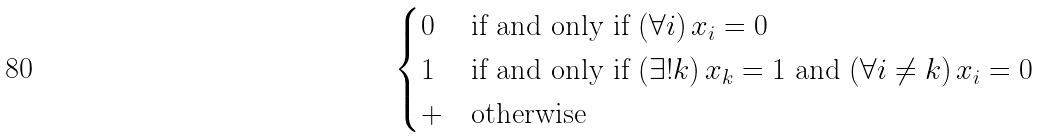Convert formula to latex. <formula><loc_0><loc_0><loc_500><loc_500>\begin{cases} 0 & \text {if and only if } ( \forall i ) \, x _ { i } = 0 \\ 1 & \text {if and only if } ( \exists ! k ) \, x _ { k } = 1 \text { and } ( \forall i \neq k ) \, x _ { i } = 0 \\ + & \text {otherwise} \end{cases}</formula> 